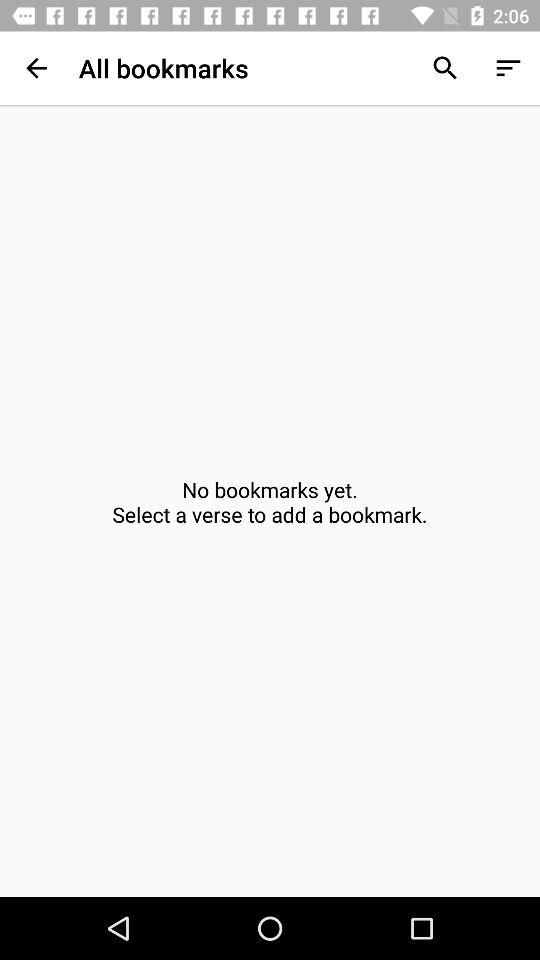Which verses have been selected?
When the provided information is insufficient, respond with <no answer>. <no answer> 